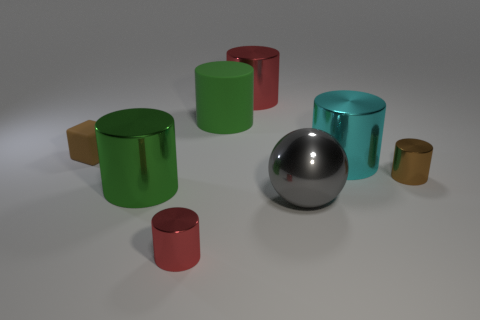Subtract all cyan metal cylinders. How many cylinders are left? 5 Subtract all cyan cylinders. How many cylinders are left? 5 Subtract 3 cylinders. How many cylinders are left? 3 Add 2 tiny blue rubber blocks. How many objects exist? 10 Subtract all yellow cylinders. Subtract all purple spheres. How many cylinders are left? 6 Subtract all blocks. How many objects are left? 7 Add 4 brown cylinders. How many brown cylinders exist? 5 Subtract 0 blue cubes. How many objects are left? 8 Subtract all large objects. Subtract all tiny brown blocks. How many objects are left? 2 Add 5 cubes. How many cubes are left? 6 